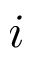<formula> <loc_0><loc_0><loc_500><loc_500>i</formula> 